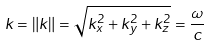Convert formula to latex. <formula><loc_0><loc_0><loc_500><loc_500>k = \| k \| = { \sqrt { k _ { x } ^ { 2 } + k _ { y } ^ { 2 } + k _ { z } ^ { 2 } } } = { \frac { \omega } { c } }</formula> 